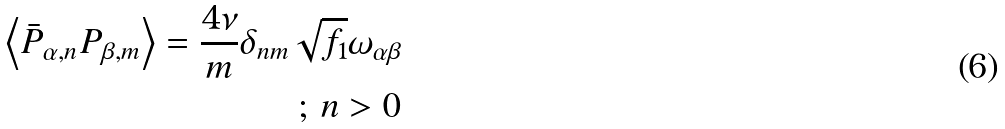<formula> <loc_0><loc_0><loc_500><loc_500>\left \langle \bar { P } _ { \alpha , n } P _ { \beta , m } \right \rangle = \frac { 4 \nu } { m } \delta _ { n m } \sqrt { f _ { 1 } } \omega _ { \alpha \beta } \\ ; \, n > 0</formula> 